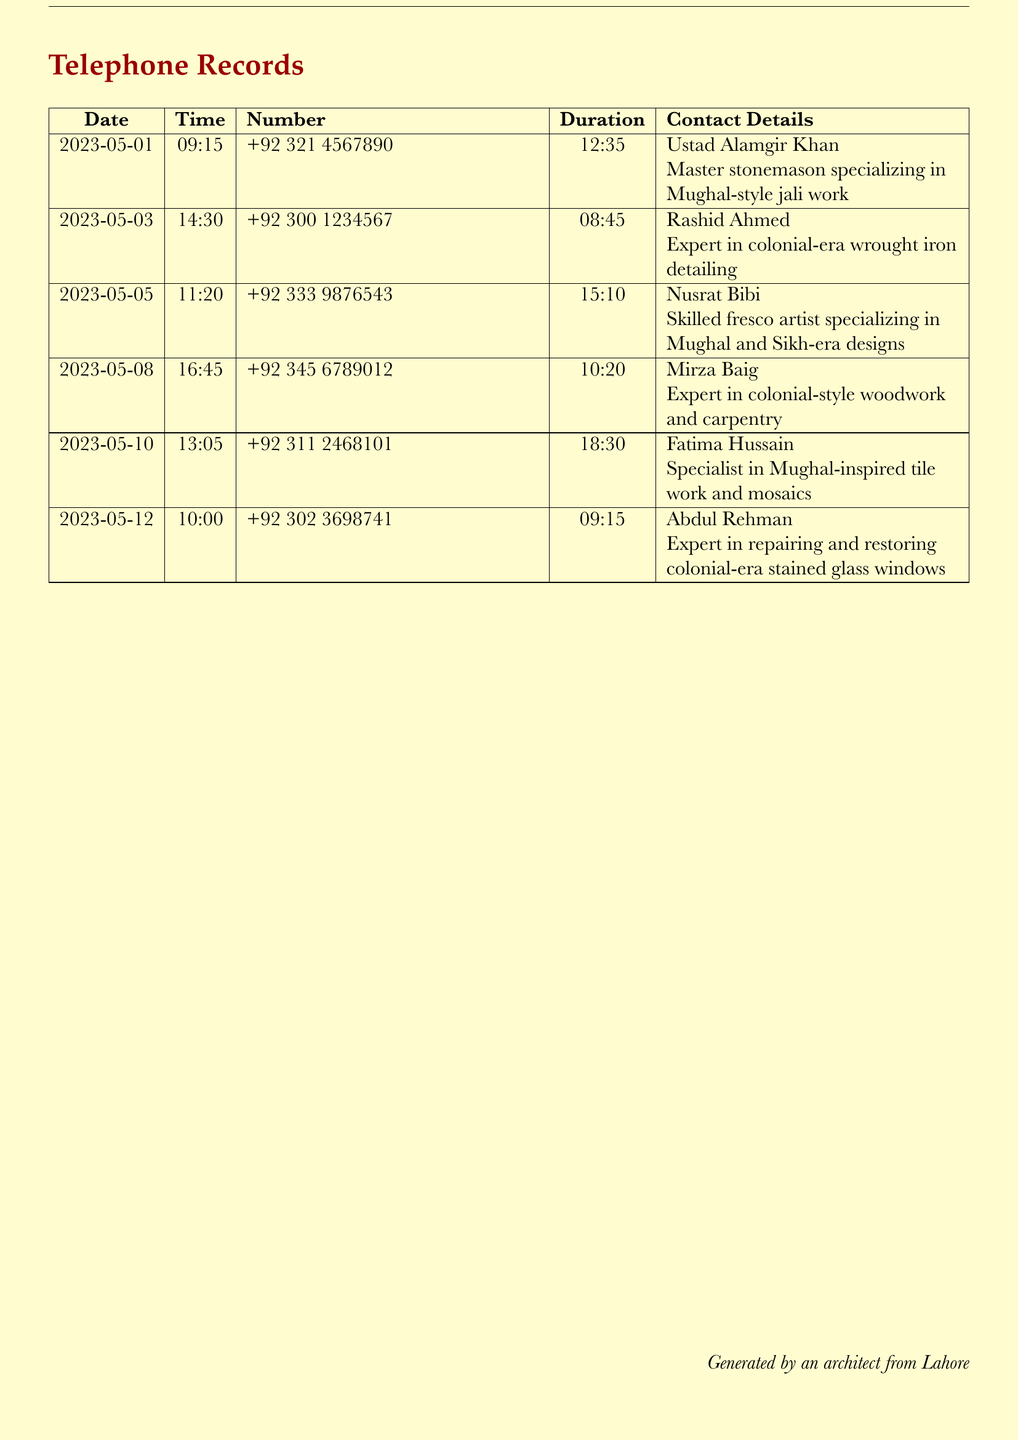what is the date of the first call? The first call was made on May 1, 2023.
Answer: May 1, 2023 who is the expert in colonial-era wrought iron detailing? The expert in colonial-era wrought iron detailing is Rashid Ahmed.
Answer: Rashid Ahmed how long was the call with Fatima Hussain? The call with Fatima Hussain lasted for 18 minutes and 30 seconds.
Answer: 18:30 which craftsman specializes in Mughal-style jali work? Ustad Alamgir Khan specializes in Mughal-style jali work.
Answer: Ustad Alamgir Khan how many craftsmen were contacted on May 5, 2023? On May 5, 2023, one craftsman, Nusrat Bibi, was contacted.
Answer: one what is the primary skill of Abdul Rehman? Abdul Rehman is an expert in repairing and restoring colonial-era stained glass windows.
Answer: repairing and restoring colonial-era stained glass windows which craftsman had the longest call duration? The craftsman with the longest call duration is Nusrat Bibi, with 15 minutes and 10 seconds.
Answer: Nusrat Bibi what is the common theme among the craftsmen listed? The common theme among the craftsmen is their specialization in traditional Mughal and colonial architectural elements.
Answer: traditional Mughal and colonial architectural elements 